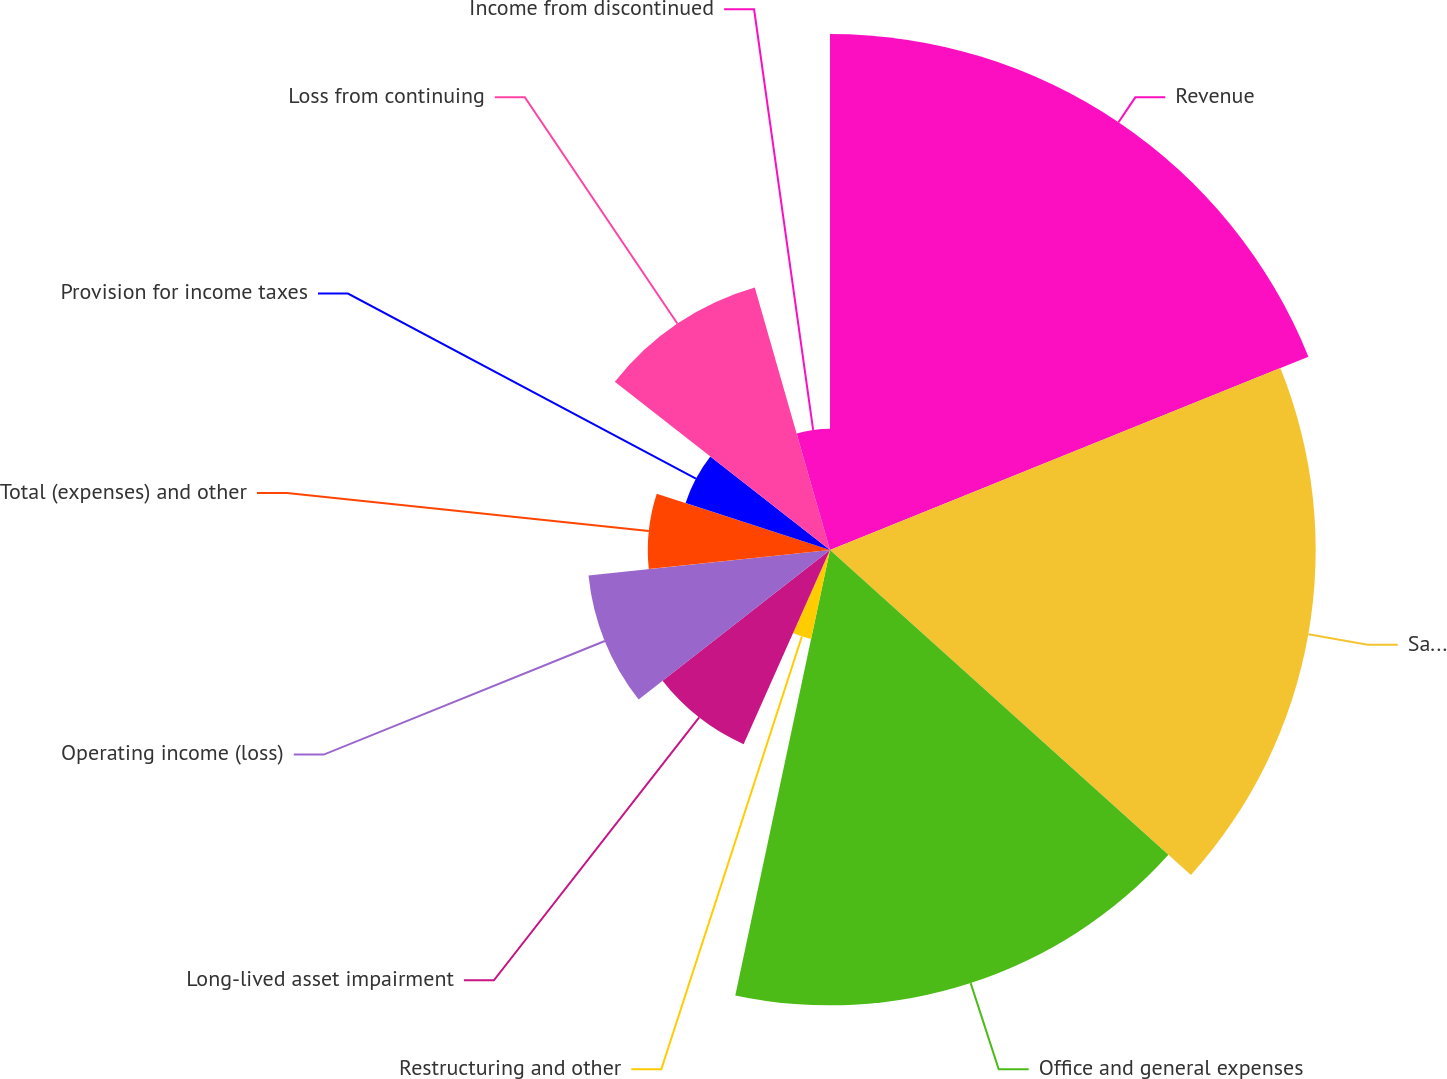Convert chart. <chart><loc_0><loc_0><loc_500><loc_500><pie_chart><fcel>Revenue<fcel>Salaries and related expenses<fcel>Office and general expenses<fcel>Restructuring and other<fcel>Long-lived asset impairment<fcel>Operating income (loss)<fcel>Total (expenses) and other<fcel>Provision for income taxes<fcel>Loss from continuing<fcel>Income from discontinued<nl><fcel>18.89%<fcel>17.78%<fcel>16.67%<fcel>3.33%<fcel>7.78%<fcel>8.89%<fcel>6.67%<fcel>5.56%<fcel>10.0%<fcel>4.44%<nl></chart> 